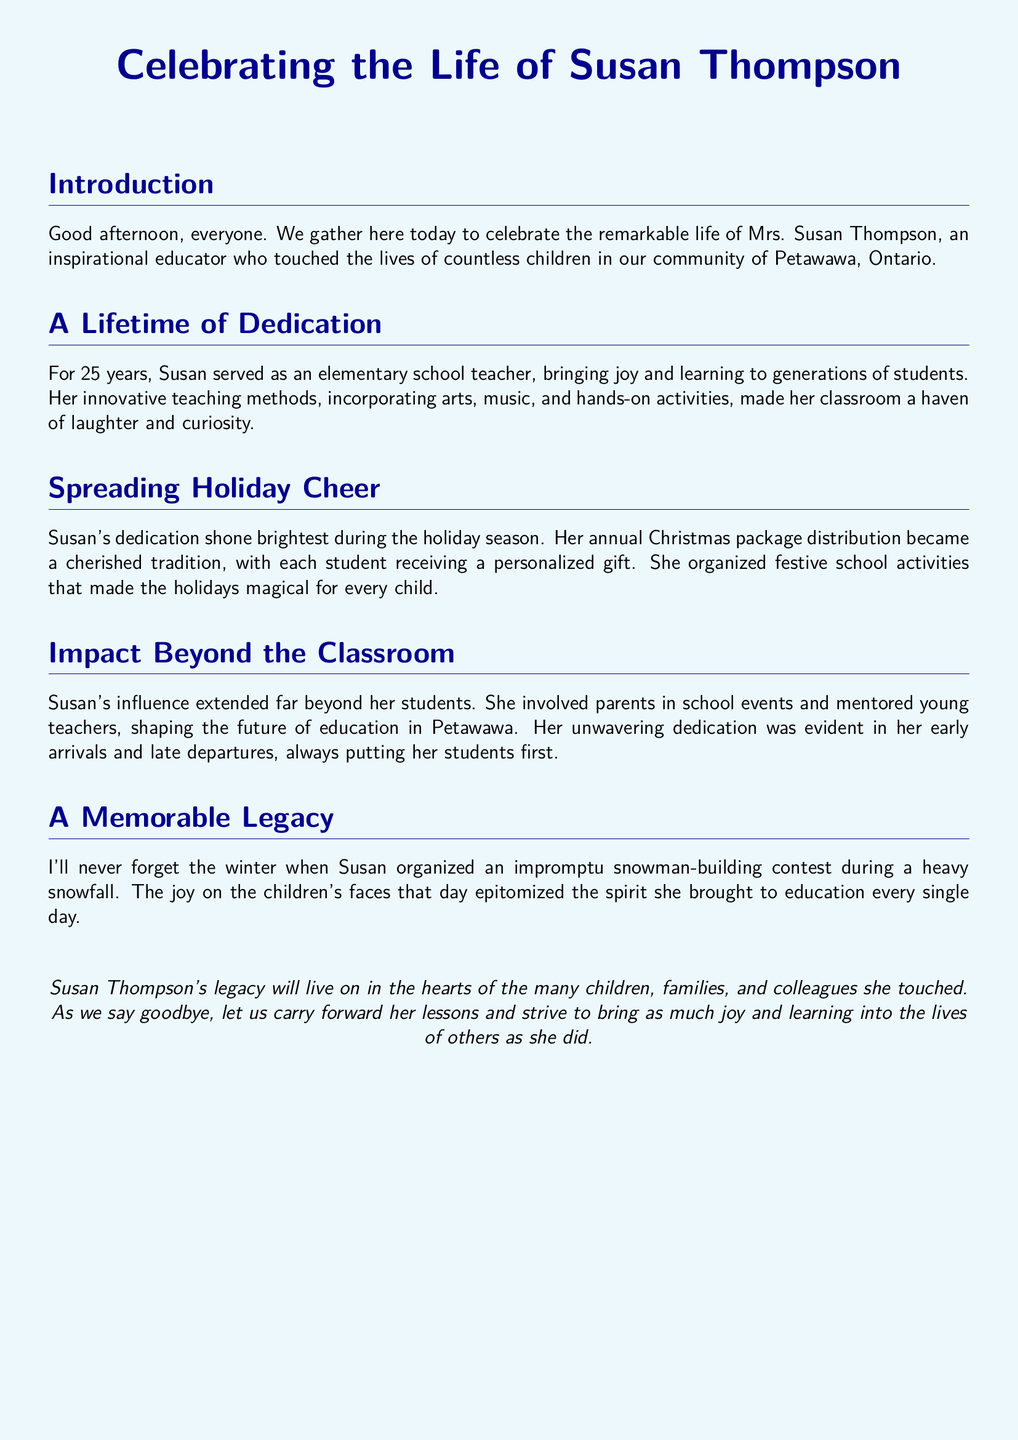What is the name of the educator being celebrated? The document specifically names the educator as Susan Thompson.
Answer: Susan Thompson How many years did Susan serve as an elementary school teacher? The document states that Susan served for 25 years.
Answer: 25 years What did Susan organize during the holiday season? The document mentions that Susan organized annual Christmas package distributions.
Answer: Christmas package distributions What was an example of an event organized by Susan during winter? The document describes a snowman-building contest that Susan organized.
Answer: Snowman-building contest What type of influence did Susan have beyond her students? The document indicates that Susan mentored young teachers and involved parents in school events.
Answer: Mentored young teachers What is noted as a cherished tradition that Susan provided? The document highlights the personalized gifts given to each student as part of her tradition.
Answer: Personalized gifts What did Susan incorporate into her teaching methods? The document mentions that she incorporated arts, music, and hands-on activities.
Answer: Arts, music, and hands-on activities What feeling did Susan's activities aim to create for the children during the holidays? The document indicates that Susan's activities aimed to make the holidays magical.
Answer: Magical What legacy did Susan leave behind? The document states that her legacy will live on in the hearts of children, families, and colleagues.
Answer: Live on in hearts 